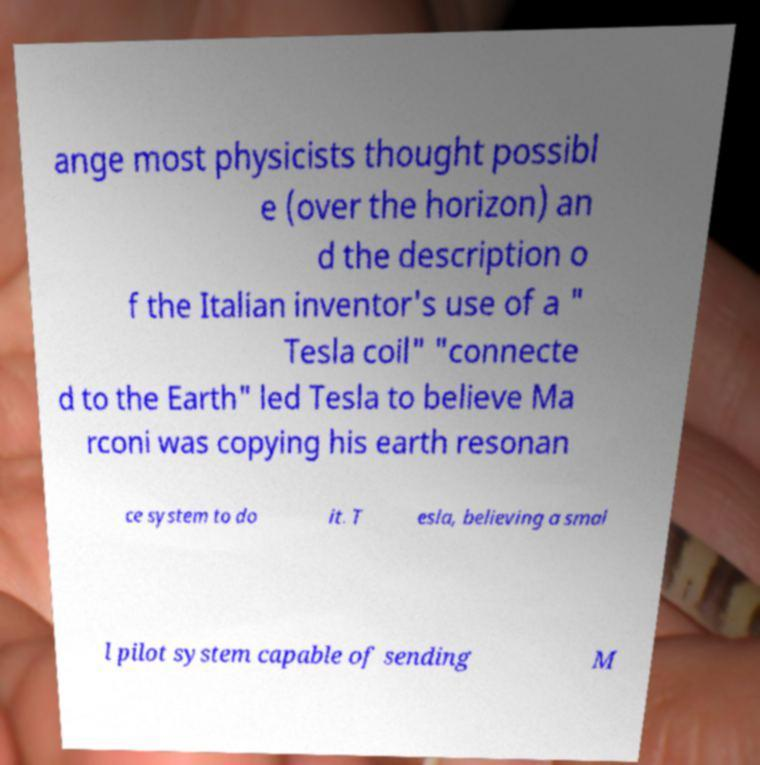Can you accurately transcribe the text from the provided image for me? ange most physicists thought possibl e (over the horizon) an d the description o f the Italian inventor's use of a " Tesla coil" "connecte d to the Earth" led Tesla to believe Ma rconi was copying his earth resonan ce system to do it. T esla, believing a smal l pilot system capable of sending M 